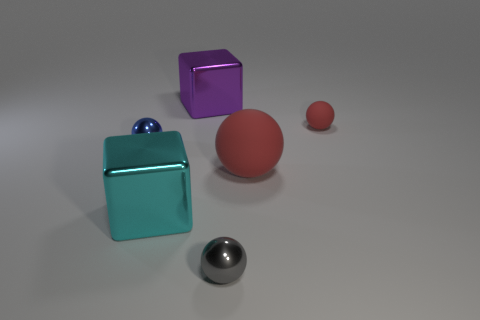Subtract all purple balls. Subtract all purple cylinders. How many balls are left? 4 Add 1 small matte objects. How many objects exist? 7 Subtract all spheres. How many objects are left? 2 Add 6 large purple shiny things. How many large purple shiny things exist? 7 Subtract 0 green balls. How many objects are left? 6 Subtract all big brown metallic balls. Subtract all small gray spheres. How many objects are left? 5 Add 2 small matte objects. How many small matte objects are left? 3 